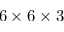<formula> <loc_0><loc_0><loc_500><loc_500>6 \times 6 \times 3</formula> 